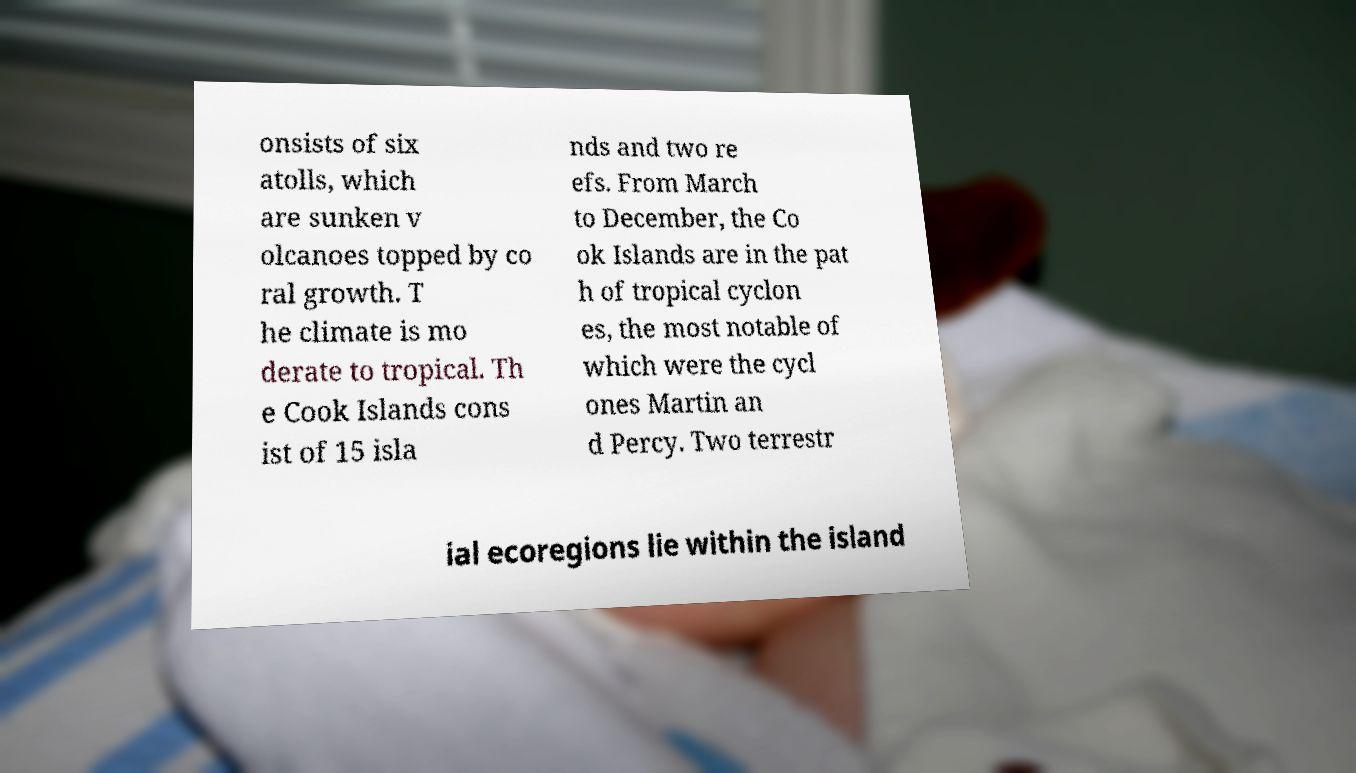What messages or text are displayed in this image? I need them in a readable, typed format. onsists of six atolls, which are sunken v olcanoes topped by co ral growth. T he climate is mo derate to tropical. Th e Cook Islands cons ist of 15 isla nds and two re efs. From March to December, the Co ok Islands are in the pat h of tropical cyclon es, the most notable of which were the cycl ones Martin an d Percy. Two terrestr ial ecoregions lie within the island 